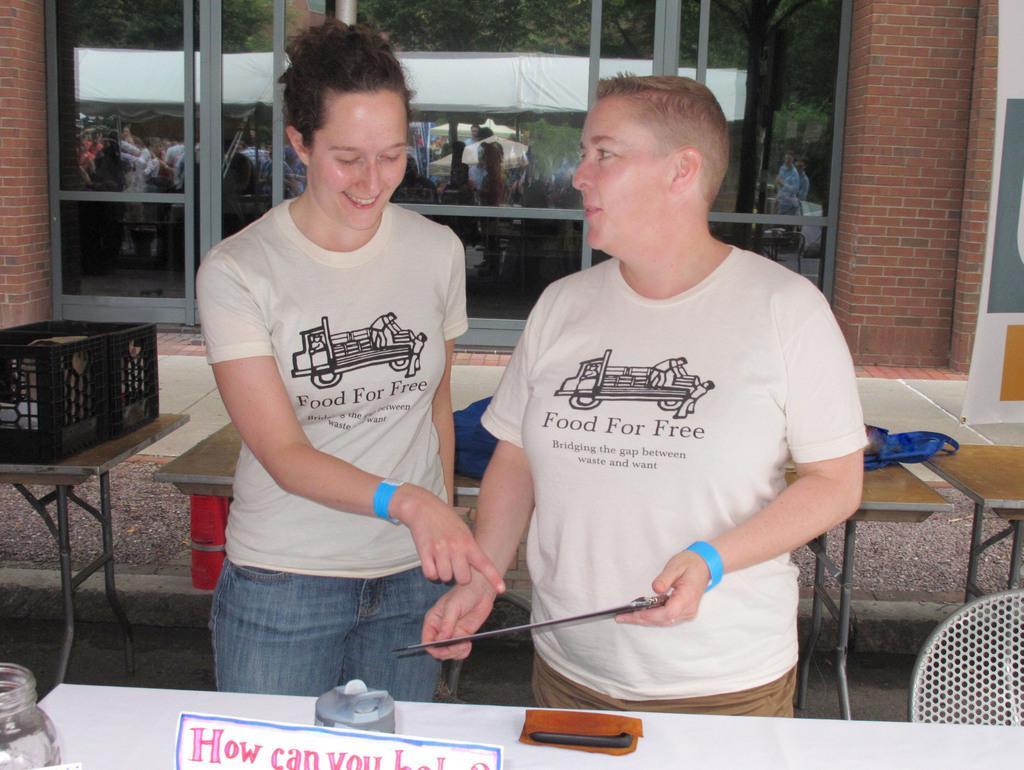Please provide a concise description of this image. These two persons are standing and wore a cream color t-shirt. In-front of this person's there is a table, on a table there is a mobile, board and jar. Backside of this person's there are tables, on this table there is a basket. This is a building with window. On this window there is a reflection of persons and trees. 